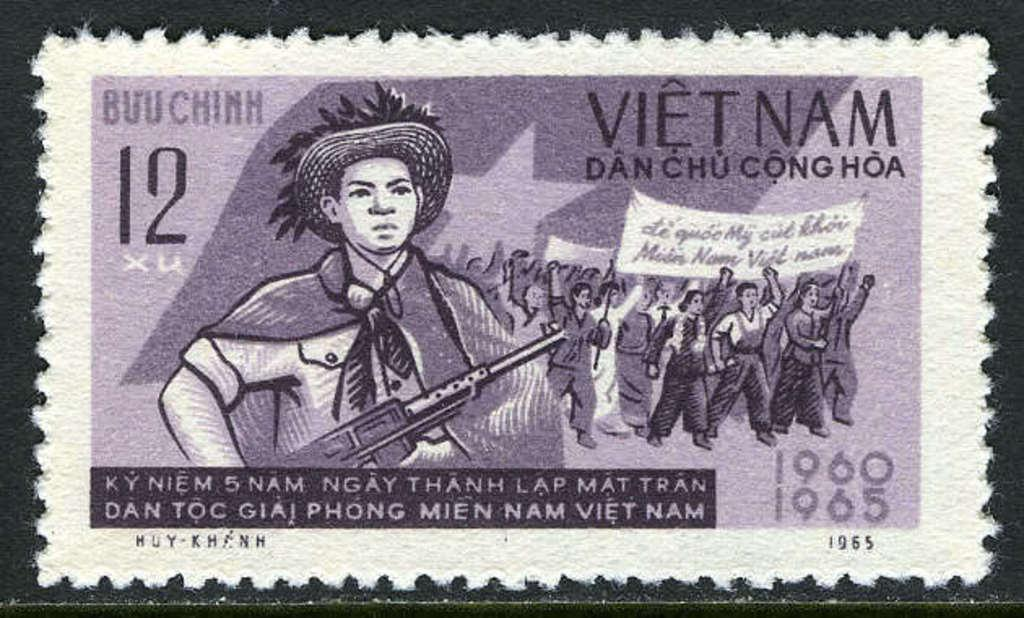What is the main subject of the image? The main subject of the image is a postage stamp. What can be seen on the postage stamp? There is a group of people on the postage stamp, and they are holding a banner in their hands. Is there any text on the postage stamp? Yes, there is text written on the postage stamp. What type of throne is visible in the image? There is no throne present in the image; it features a postage stamp with a group of people holding a banner. What material is the brass used for in the image? There is no brass present in the image. 